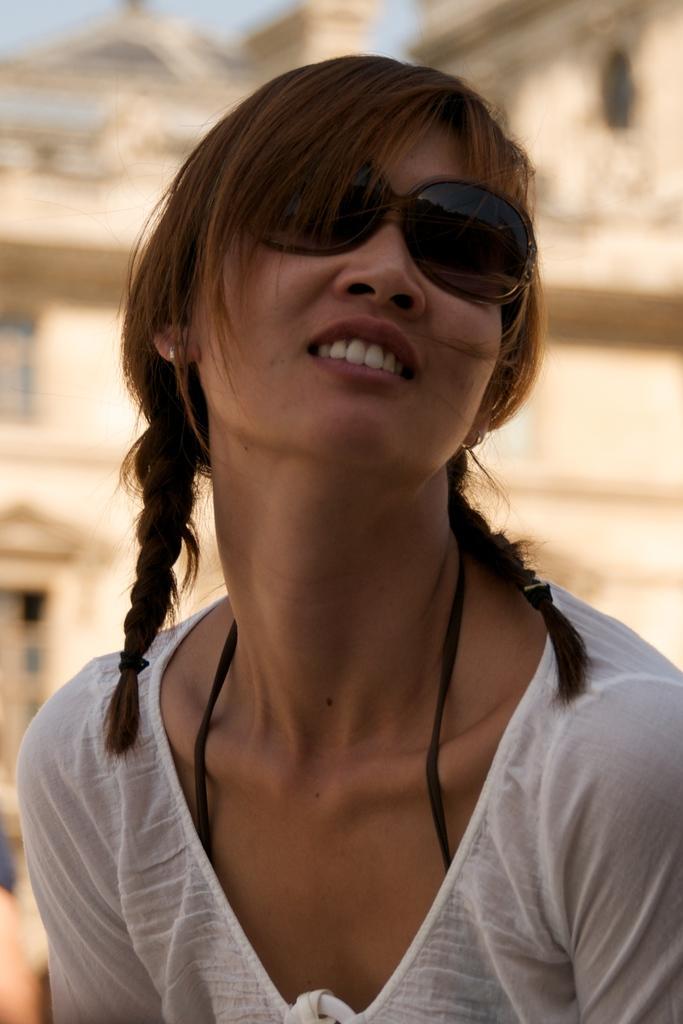Could you give a brief overview of what you see in this image? In this image we can see a girl. She is wearing white color top. Behind building is there. 